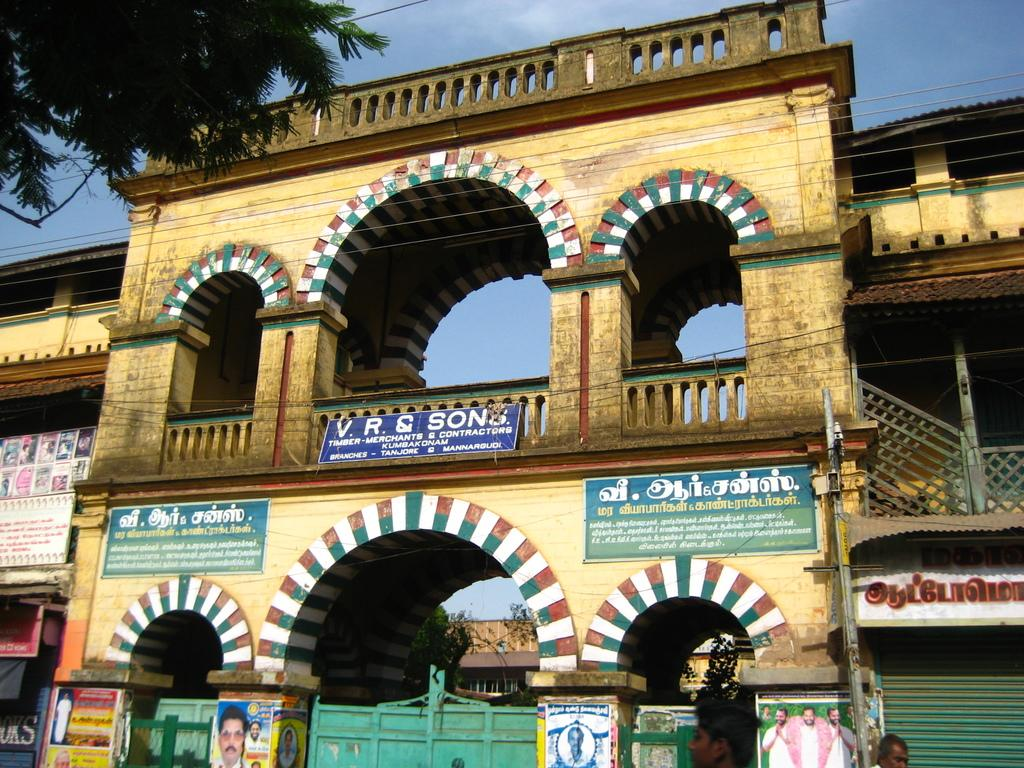What type of structure is visible in the image? There is a building in the image. What is attached to the building? There are posters on the building. What can be found on the posters? There is text on the posters. Where is the tree located in the image? There is a tree at the top left of the image. What is the current temperature in the image? There is no information about the temperature in the image. What shape is the tree in the image? The shape of the tree cannot be determined from the image alone, as it is only a small part of the overall image. 